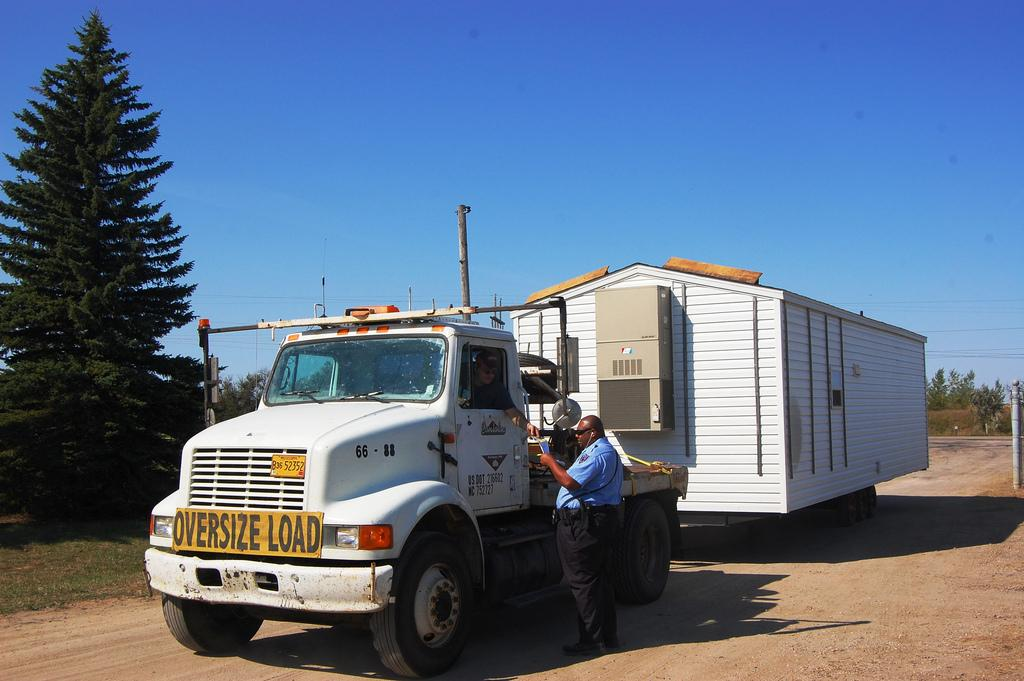What is on the road in the image? There is a vehicle on the road in the image. How many people are in the image? There are two people in the image. What type of vegetation is present in the image? Grass is present in the image. What structures can be seen in the image? There are poles in the image. What else can be seen in the image besides the vehicle and people? Trees are visible in the image, and there are some objects present. What is visible in the background of the image? The sky is visible in the background of the image. How does the vehicle test its grip on the road in the image? The vehicle does not test its grip in the image; it is stationary on the road. What type of fear can be seen on the faces of the people in the image? There is no indication of fear on the faces of the people in the image. 